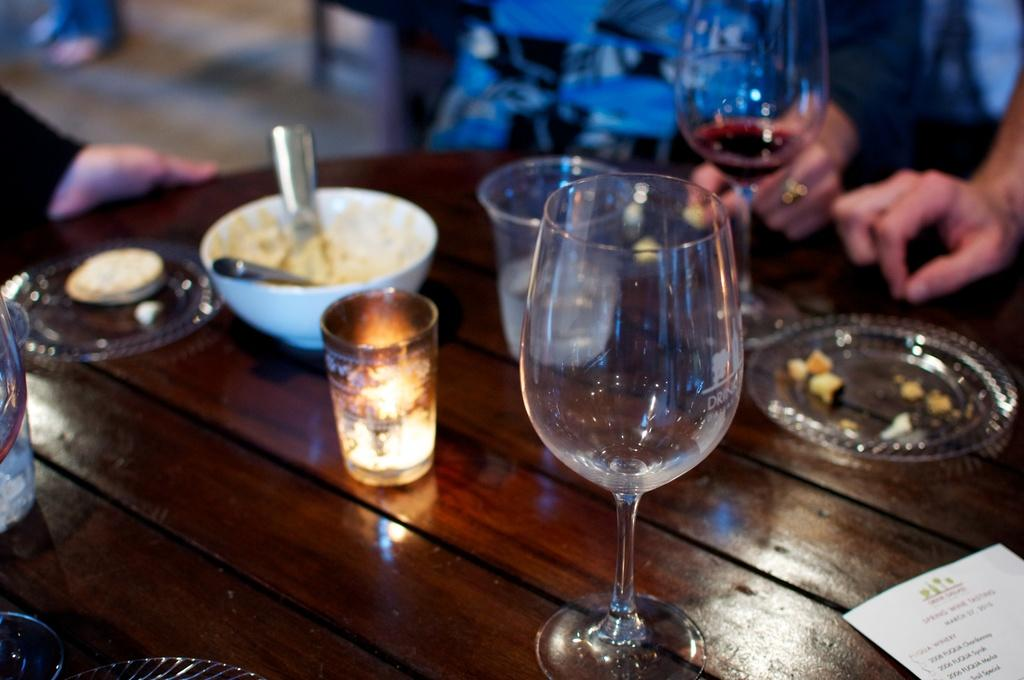What objects are on the table in the image? There are plates, a bowl, glasses, a candle, and paper on the table. What type of container is used for holding liquids in the image? Glasses are used for holding liquids in the image. What is the source of light on the table in the image? There is a candle on the table, which serves as a source of light. How many persons are sitting beside the table in the image? Persons are sitting on chairs beside the table, but the exact number is not specified in the facts. What type of food is being prepared at the faucet in the image? There is no faucet or food preparation visible in the image. 